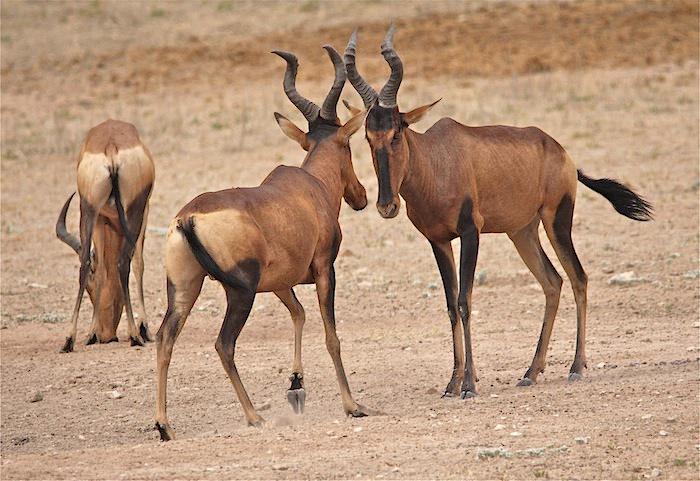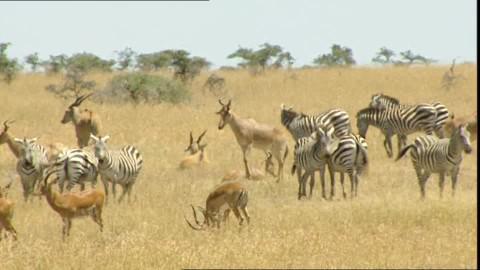The first image is the image on the left, the second image is the image on the right. Given the left and right images, does the statement "Zebra are present in a field with horned animals in one image." hold true? Answer yes or no. Yes. The first image is the image on the left, the second image is the image on the right. Analyze the images presented: Is the assertion "The right photo contains two kinds of animals." valid? Answer yes or no. Yes. 